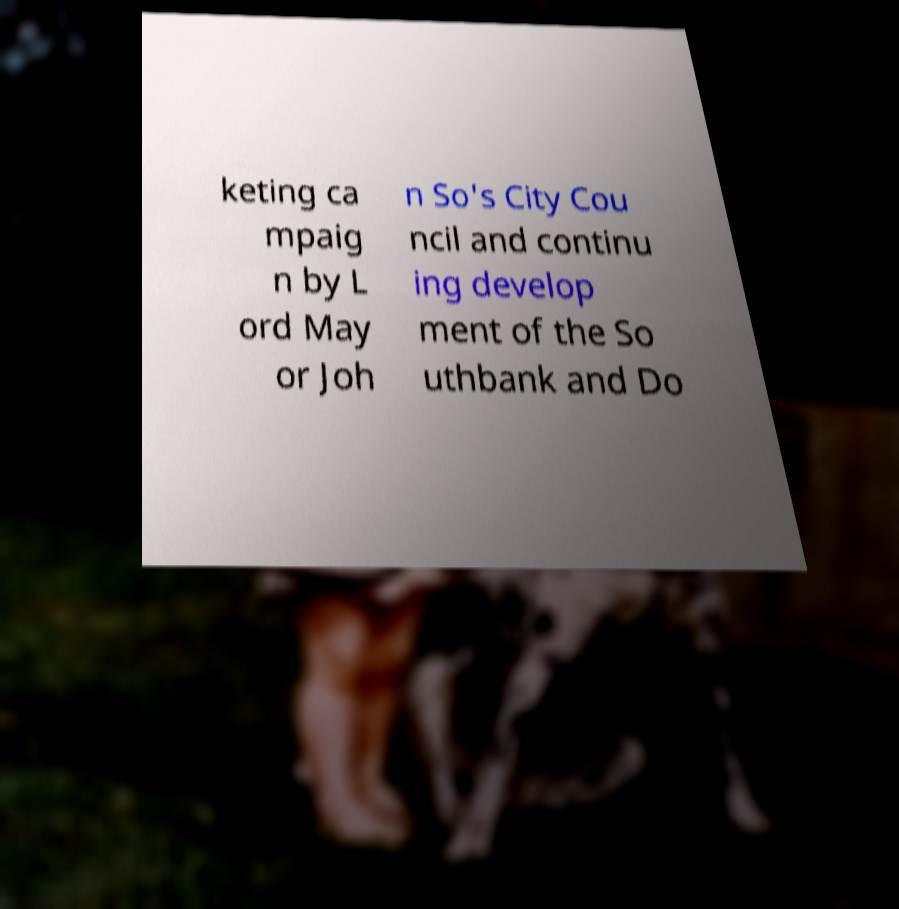Could you assist in decoding the text presented in this image and type it out clearly? keting ca mpaig n by L ord May or Joh n So's City Cou ncil and continu ing develop ment of the So uthbank and Do 